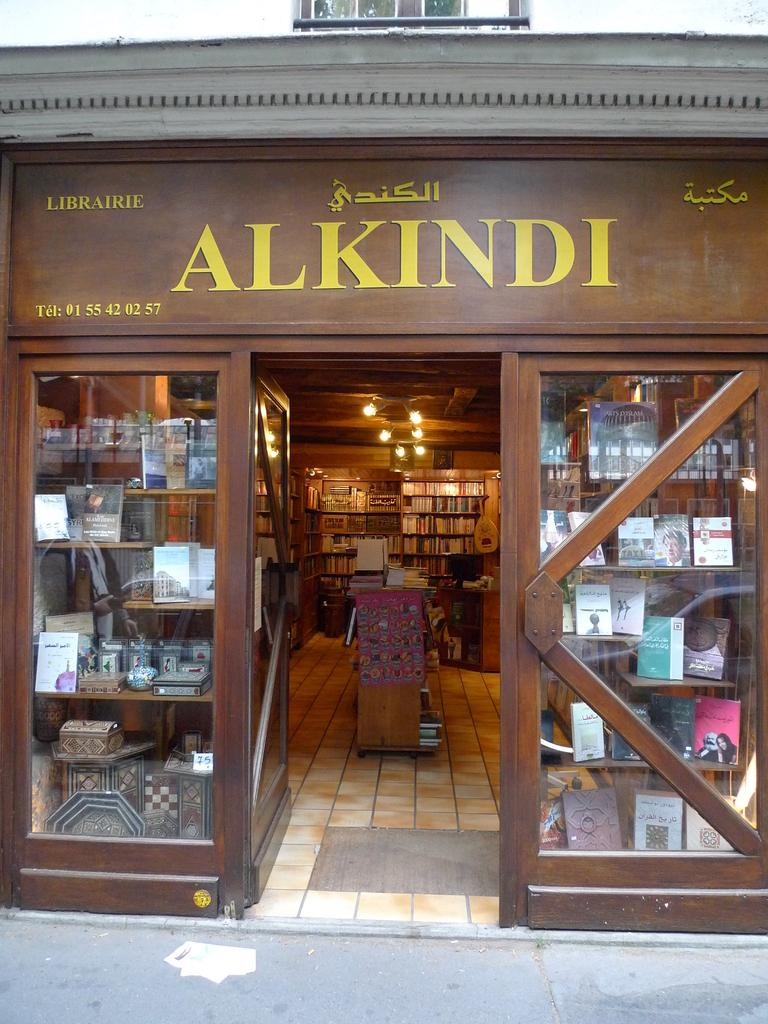<image>
Render a clear and concise summary of the photo. the outside of a shop that says 'alkindi' above the doors 